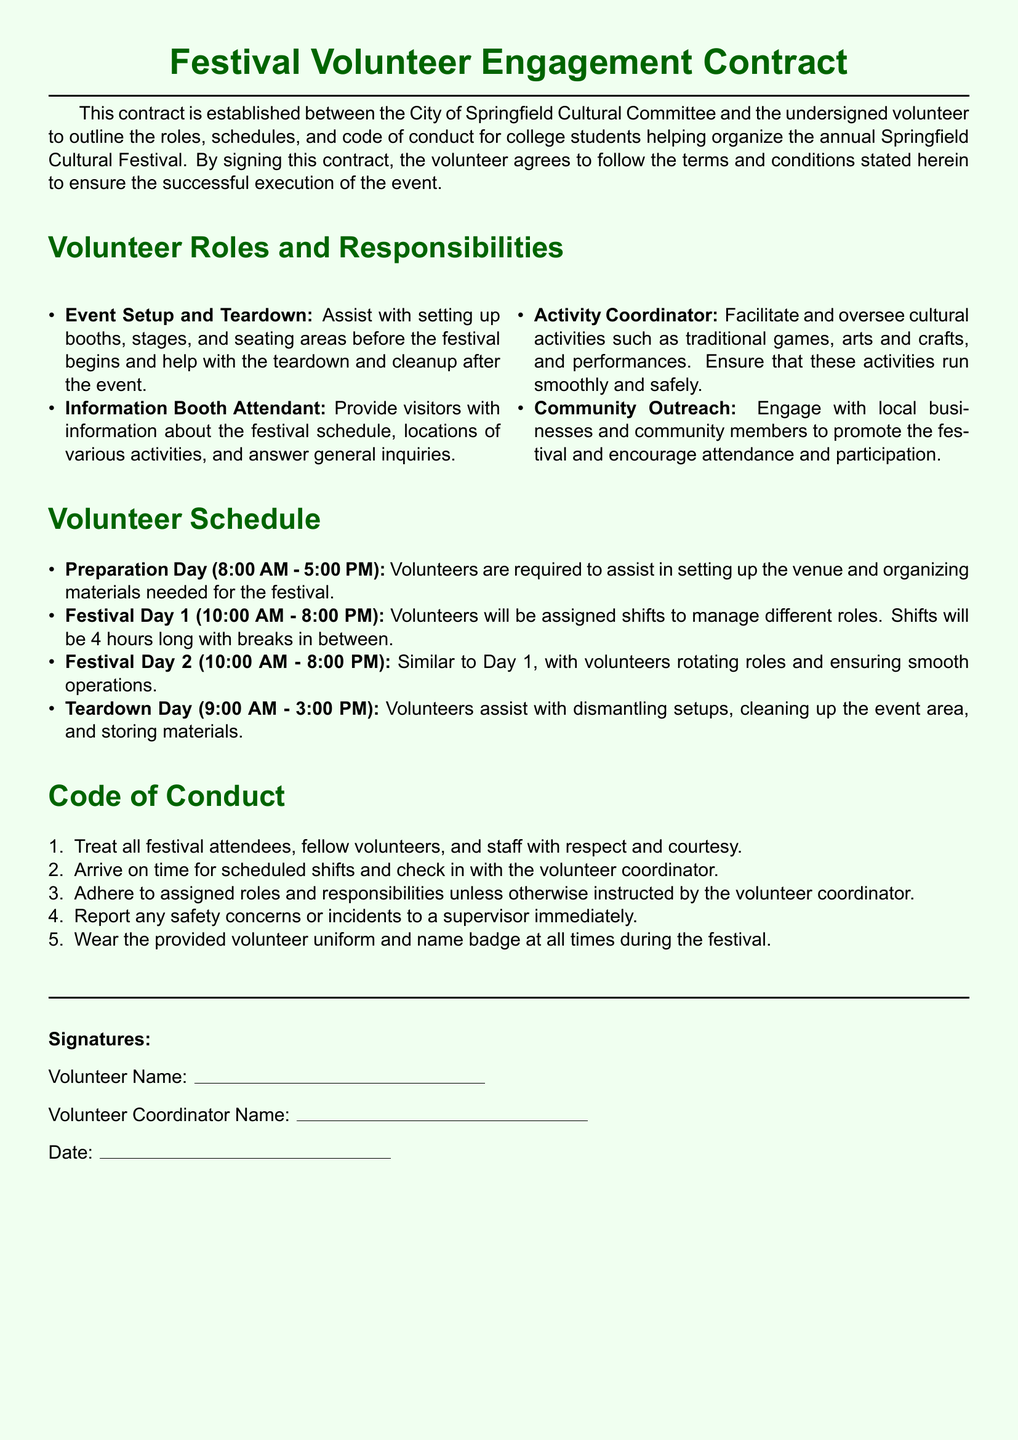What is the title of the document? The title is found at the top of the document, indicating its purpose.
Answer: Festival Volunteer Engagement Contract Who is the contract established between? The contract specifies the two parties involved in the agreement.
Answer: City of Springfield Cultural Committee and the undersigned volunteer What are the hours for Preparation Day? This information is outlined in the volunteer schedule section of the document.
Answer: 8:00 AM - 5:00 PM What role involves providing information about festival activities? This role is explicitly stated under the volunteer roles and responsibilities.
Answer: Information Booth Attendant What is the maximum length of each shift during the festival days? This detail is mentioned in the schedule section regarding shift length.
Answer: 4 hours What are volunteers expected to wear during the festival? This requirement is included in the code of conduct section.
Answer: Volunteer uniform and name badge What should a volunteer do if they notice a safety concern? This guidance is provided in the code of conduct to ensure safety.
Answer: Report to a supervisor immediately What is the purpose of this contract? The purpose is clearly defined at the beginning of the document.
Answer: To outline the roles, schedules, and code of conduct for volunteers What is the date format for the signatures section? This detail can be inferred from the line provided under the signatures section.
Answer: Not specified in the document 